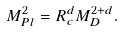Convert formula to latex. <formula><loc_0><loc_0><loc_500><loc_500>M _ { P l } ^ { 2 } = R _ { c } ^ { d } M _ { D } ^ { 2 + d } .</formula> 